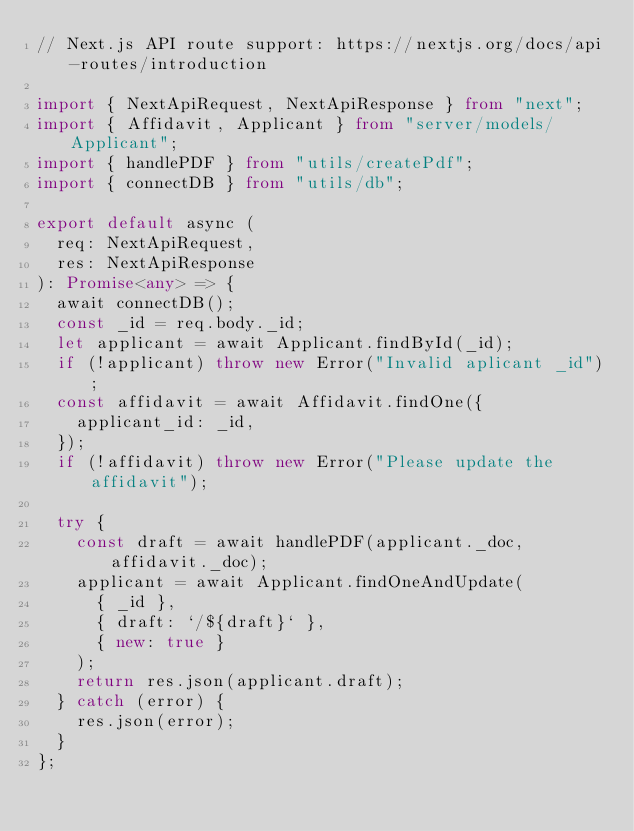<code> <loc_0><loc_0><loc_500><loc_500><_TypeScript_>// Next.js API route support: https://nextjs.org/docs/api-routes/introduction

import { NextApiRequest, NextApiResponse } from "next";
import { Affidavit, Applicant } from "server/models/Applicant";
import { handlePDF } from "utils/createPdf";
import { connectDB } from "utils/db";

export default async (
  req: NextApiRequest,
  res: NextApiResponse
): Promise<any> => {
  await connectDB();
  const _id = req.body._id;
  let applicant = await Applicant.findById(_id);
  if (!applicant) throw new Error("Invalid aplicant _id");
  const affidavit = await Affidavit.findOne({
    applicant_id: _id,
  });
  if (!affidavit) throw new Error("Please update the affidavit");

  try {
    const draft = await handlePDF(applicant._doc, affidavit._doc);
    applicant = await Applicant.findOneAndUpdate(
      { _id },
      { draft: `/${draft}` },
      { new: true }
    );
    return res.json(applicant.draft);
  } catch (error) {
    res.json(error);
  }
};
</code> 